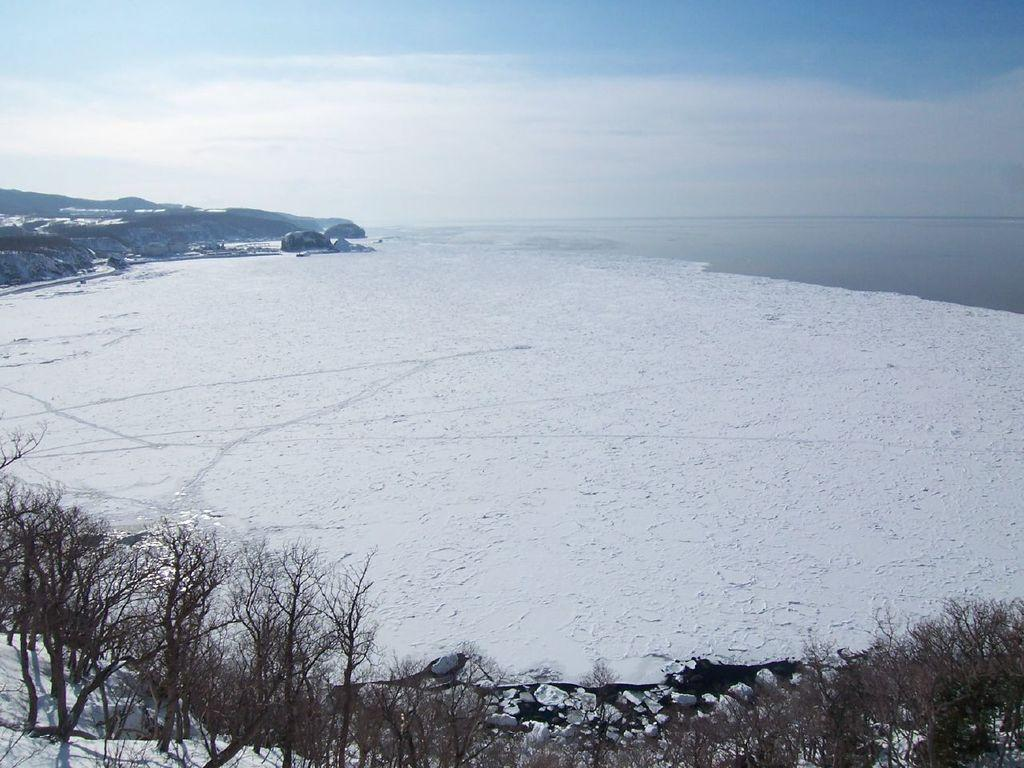What type of terrain is visible in the image? There are hills in the image. What type of vegetation is present in the image? There are trees in the image. What is the weather like in the image? There is snow visible in the image, indicating a cold or wintery environment. What can be seen on the right side of the image? There is water on the right side of the image. What is visible in the background of the image? The sky is visible in the background of the image. What type of stocking is hanging from the trees in the image? There are no stockings hanging from the trees in the image; only trees, hills, snow, water, and sky are visible. 